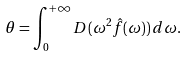Convert formula to latex. <formula><loc_0><loc_0><loc_500><loc_500>\theta = \int _ { 0 } ^ { + \infty } D ( \omega ^ { 2 } \hat { f } ( \omega ) ) \, d \omega .</formula> 